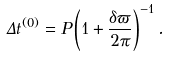<formula> <loc_0><loc_0><loc_500><loc_500>\Delta t ^ { ( 0 ) } = P \left ( 1 + \frac { \delta \varpi } { 2 \pi } \right ) ^ { - 1 } .</formula> 